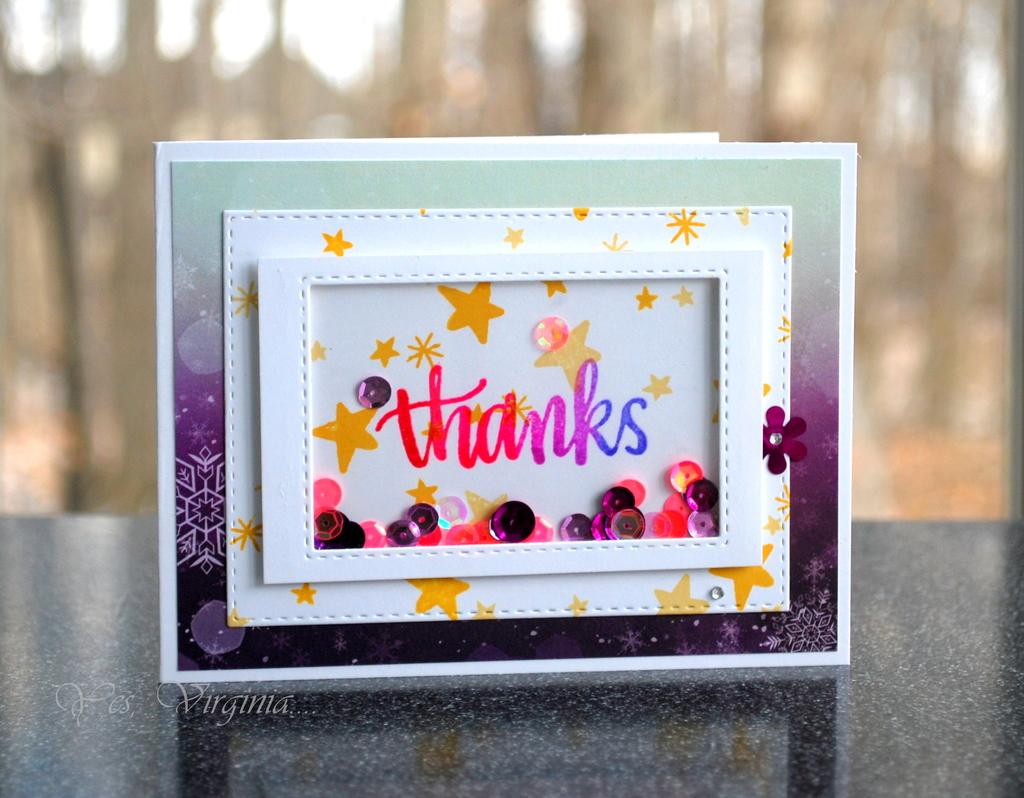<image>
Provide a brief description of the given image. A colorful greeting cards which says, "thanks" is sitting on a countertop. 